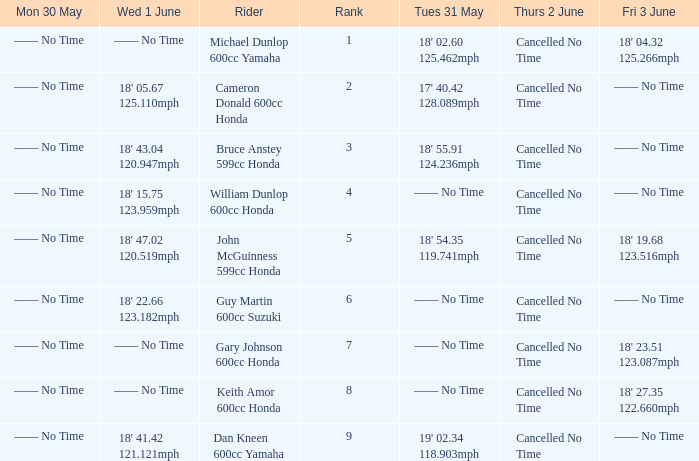Help me parse the entirety of this table. {'header': ['Mon 30 May', 'Wed 1 June', 'Rider', 'Rank', 'Tues 31 May', 'Thurs 2 June', 'Fri 3 June'], 'rows': [['—— No Time', '—— No Time', 'Michael Dunlop 600cc Yamaha', '1', "18' 02.60 125.462mph", 'Cancelled No Time', "18' 04.32 125.266mph"], ['—— No Time', "18' 05.67 125.110mph", 'Cameron Donald 600cc Honda', '2', "17' 40.42 128.089mph", 'Cancelled No Time', '—— No Time'], ['—— No Time', "18' 43.04 120.947mph", 'Bruce Anstey 599cc Honda', '3', "18' 55.91 124.236mph", 'Cancelled No Time', '—— No Time'], ['—— No Time', "18' 15.75 123.959mph", 'William Dunlop 600cc Honda', '4', '—— No Time', 'Cancelled No Time', '—— No Time'], ['—— No Time', "18' 47.02 120.519mph", 'John McGuinness 599cc Honda', '5', "18' 54.35 119.741mph", 'Cancelled No Time', "18' 19.68 123.516mph"], ['—— No Time', "18' 22.66 123.182mph", 'Guy Martin 600cc Suzuki', '6', '—— No Time', 'Cancelled No Time', '—— No Time'], ['—— No Time', '—— No Time', 'Gary Johnson 600cc Honda', '7', '—— No Time', 'Cancelled No Time', "18' 23.51 123.087mph"], ['—— No Time', '—— No Time', 'Keith Amor 600cc Honda', '8', '—— No Time', 'Cancelled No Time', "18' 27.35 122.660mph"], ['—— No Time', "18' 41.42 121.121mph", 'Dan Kneen 600cc Yamaha', '9', "19' 02.34 118.903mph", 'Cancelled No Time', '—— No Time']]} What is the Fri 3 June time for the rider with a Weds 1 June time of 18' 22.66 123.182mph? —— No Time. 